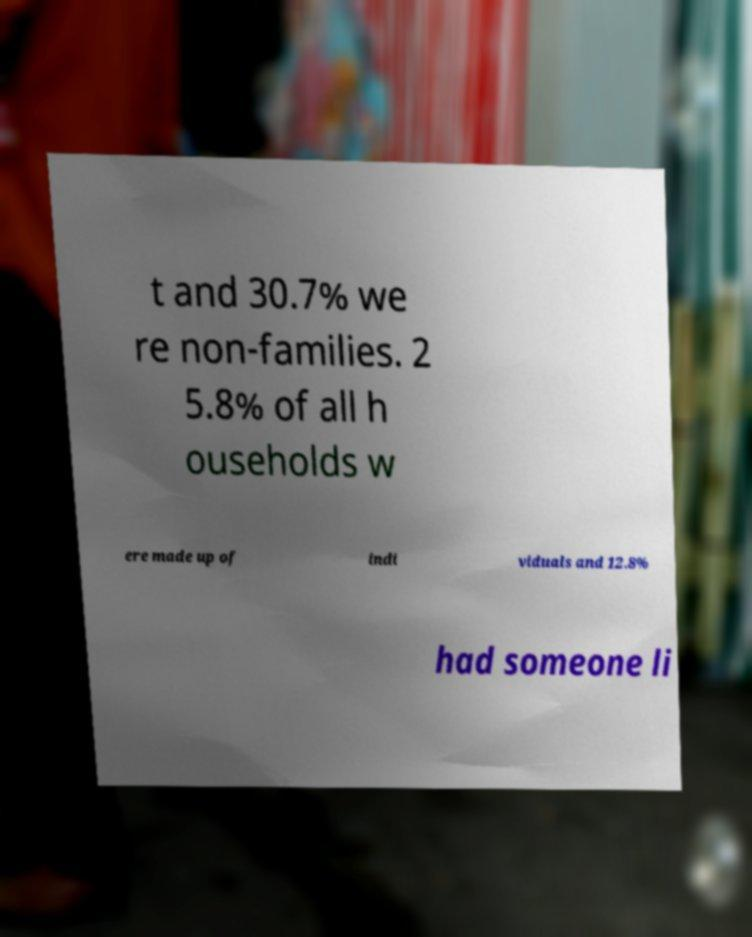For documentation purposes, I need the text within this image transcribed. Could you provide that? t and 30.7% we re non-families. 2 5.8% of all h ouseholds w ere made up of indi viduals and 12.8% had someone li 